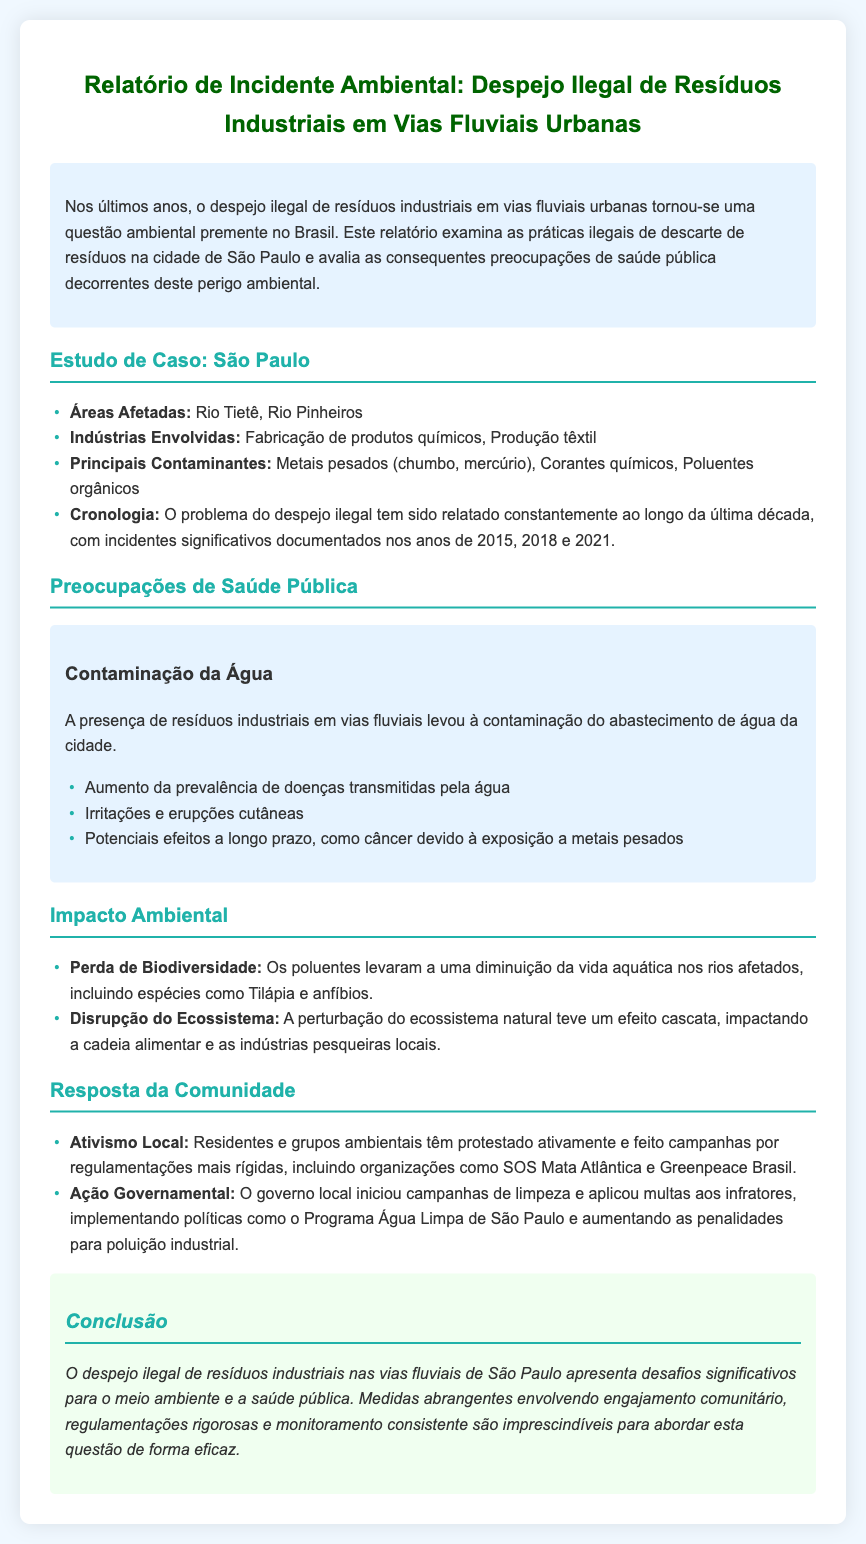Qual é o título do relatório? O título do relatório é destacado na parte superior do documento, eis que diz respeito ao incidente de despejo ilegal.
Answer: Relatório de Incidente Ambiental: Despejo Ilegal de Resíduos Industriais em Vias Fluviais Urbanas Quais são os principais contaminantes mencionados? Os contaminantes estão listados na seção de estudo de caso.
Answer: Metais pesados (chumbo, mercúrio), Corantes químicos, Poluentes orgânicos Quais rios estão afetados pelo problema? Os rios afetados estão listados claramente na seção de estudo de caso.
Answer: Rio Tietê, Rio Pinheiros Quantas décadas o problema de despejo ilegal tem sido relatado? Uma década é mencionada especificamente na cronologia dos incidentes documentados.
Answer: Uma Qual é uma das principais doenças mencionadas como preocupação de saúde pública? As doenças transmitidas pela água são citadas diretamente nas preocupações de saúde pública.
Answer: Doenças transmitidas pela água Qual ação o governo local iniciou? A ação do governo é citada na seção de resposta da comunidade.
Answer: Campanhas de limpeza Quem são os grupos que protestam contra o despejo ilegal? Os grupos que protestam são mencionados na seção de resposta da comunidade.
Answer: SOS Mata Atlântica e Greenpeace Brasil Qual é uma consequência de longo prazo da exposição a contaminantes? A consequência de longo prazo é discutida nas preocupações de saúde pública.
Answer: Câncer O que é o Programa Água Limpa? O programa é mencionado como uma das iniciativas do governo para abordar o problema.
Answer: Programa Água Limpa de São Paulo 